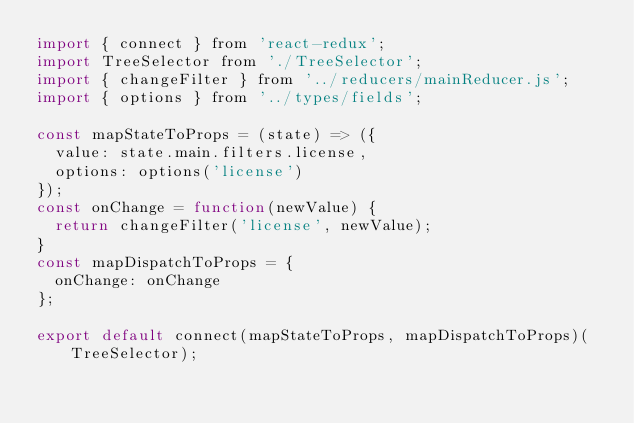<code> <loc_0><loc_0><loc_500><loc_500><_JavaScript_>import { connect } from 'react-redux';
import TreeSelector from './TreeSelector';
import { changeFilter } from '../reducers/mainReducer.js';
import { options } from '../types/fields';

const mapStateToProps = (state) => ({
  value: state.main.filters.license,
  options: options('license')
});
const onChange = function(newValue) {
  return changeFilter('license', newValue);
}
const mapDispatchToProps = {
  onChange: onChange
};

export default connect(mapStateToProps, mapDispatchToProps)(TreeSelector);
</code> 